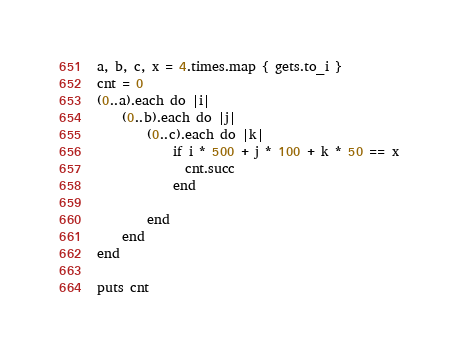Convert code to text. <code><loc_0><loc_0><loc_500><loc_500><_Ruby_>a, b, c, x = 4.times.map { gets.to_i }
cnt = 0
(0..a).each do |i|
    (0..b).each do |j|
        (0..c).each do |k|
            if i * 500 + j * 100 + k * 50 == x
              cnt.succ
            end
          
        end
    end
end

puts cnt</code> 